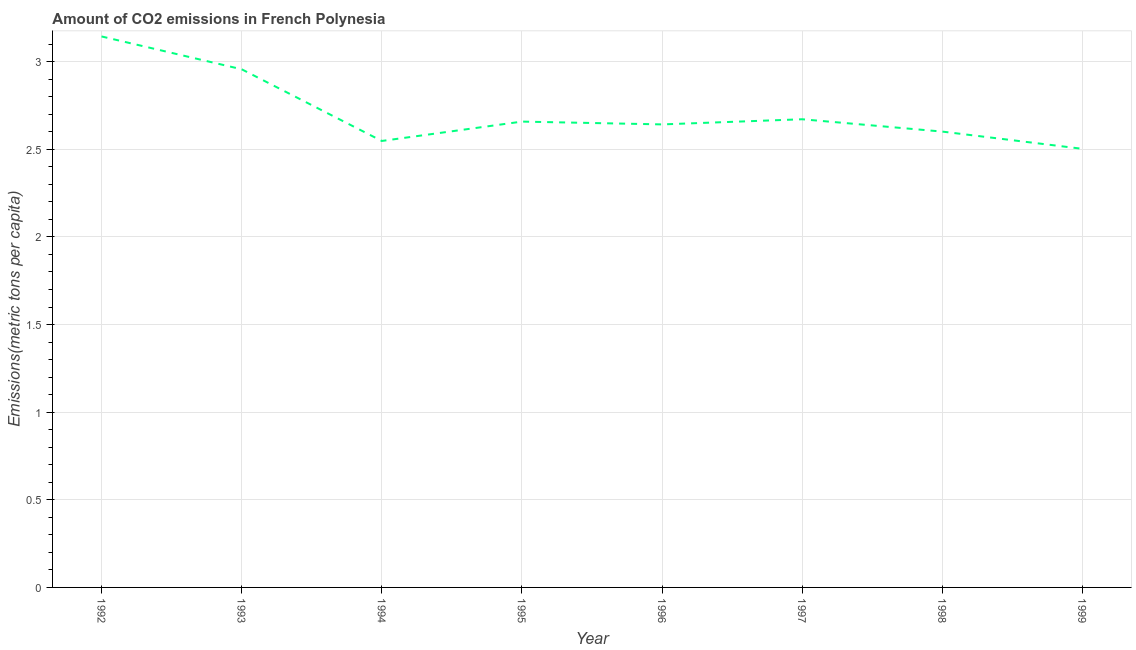What is the amount of co2 emissions in 1999?
Make the answer very short. 2.5. Across all years, what is the maximum amount of co2 emissions?
Offer a very short reply. 3.14. Across all years, what is the minimum amount of co2 emissions?
Ensure brevity in your answer.  2.5. What is the sum of the amount of co2 emissions?
Provide a short and direct response. 21.72. What is the difference between the amount of co2 emissions in 1992 and 1998?
Make the answer very short. 0.54. What is the average amount of co2 emissions per year?
Your answer should be compact. 2.72. What is the median amount of co2 emissions?
Ensure brevity in your answer.  2.65. What is the ratio of the amount of co2 emissions in 1993 to that in 1998?
Your response must be concise. 1.14. What is the difference between the highest and the second highest amount of co2 emissions?
Provide a short and direct response. 0.19. Is the sum of the amount of co2 emissions in 1994 and 1999 greater than the maximum amount of co2 emissions across all years?
Offer a very short reply. Yes. What is the difference between the highest and the lowest amount of co2 emissions?
Offer a terse response. 0.64. In how many years, is the amount of co2 emissions greater than the average amount of co2 emissions taken over all years?
Keep it short and to the point. 2. Does the amount of co2 emissions monotonically increase over the years?
Offer a terse response. No. How many lines are there?
Your response must be concise. 1. What is the difference between two consecutive major ticks on the Y-axis?
Provide a short and direct response. 0.5. Does the graph contain any zero values?
Your response must be concise. No. Does the graph contain grids?
Your response must be concise. Yes. What is the title of the graph?
Provide a succinct answer. Amount of CO2 emissions in French Polynesia. What is the label or title of the X-axis?
Provide a short and direct response. Year. What is the label or title of the Y-axis?
Provide a succinct answer. Emissions(metric tons per capita). What is the Emissions(metric tons per capita) in 1992?
Ensure brevity in your answer.  3.14. What is the Emissions(metric tons per capita) of 1993?
Make the answer very short. 2.96. What is the Emissions(metric tons per capita) of 1994?
Keep it short and to the point. 2.55. What is the Emissions(metric tons per capita) in 1995?
Your answer should be very brief. 2.66. What is the Emissions(metric tons per capita) in 1996?
Make the answer very short. 2.64. What is the Emissions(metric tons per capita) in 1997?
Provide a short and direct response. 2.67. What is the Emissions(metric tons per capita) in 1998?
Keep it short and to the point. 2.6. What is the Emissions(metric tons per capita) of 1999?
Your response must be concise. 2.5. What is the difference between the Emissions(metric tons per capita) in 1992 and 1993?
Ensure brevity in your answer.  0.19. What is the difference between the Emissions(metric tons per capita) in 1992 and 1994?
Provide a short and direct response. 0.6. What is the difference between the Emissions(metric tons per capita) in 1992 and 1995?
Provide a succinct answer. 0.49. What is the difference between the Emissions(metric tons per capita) in 1992 and 1996?
Offer a very short reply. 0.5. What is the difference between the Emissions(metric tons per capita) in 1992 and 1997?
Offer a very short reply. 0.47. What is the difference between the Emissions(metric tons per capita) in 1992 and 1998?
Provide a succinct answer. 0.54. What is the difference between the Emissions(metric tons per capita) in 1992 and 1999?
Offer a very short reply. 0.64. What is the difference between the Emissions(metric tons per capita) in 1993 and 1994?
Provide a short and direct response. 0.41. What is the difference between the Emissions(metric tons per capita) in 1993 and 1995?
Offer a terse response. 0.3. What is the difference between the Emissions(metric tons per capita) in 1993 and 1996?
Offer a terse response. 0.31. What is the difference between the Emissions(metric tons per capita) in 1993 and 1997?
Ensure brevity in your answer.  0.29. What is the difference between the Emissions(metric tons per capita) in 1993 and 1998?
Provide a short and direct response. 0.36. What is the difference between the Emissions(metric tons per capita) in 1993 and 1999?
Make the answer very short. 0.45. What is the difference between the Emissions(metric tons per capita) in 1994 and 1995?
Your response must be concise. -0.11. What is the difference between the Emissions(metric tons per capita) in 1994 and 1996?
Make the answer very short. -0.09. What is the difference between the Emissions(metric tons per capita) in 1994 and 1997?
Provide a succinct answer. -0.12. What is the difference between the Emissions(metric tons per capita) in 1994 and 1998?
Offer a very short reply. -0.05. What is the difference between the Emissions(metric tons per capita) in 1994 and 1999?
Your answer should be compact. 0.04. What is the difference between the Emissions(metric tons per capita) in 1995 and 1996?
Offer a very short reply. 0.02. What is the difference between the Emissions(metric tons per capita) in 1995 and 1997?
Your answer should be compact. -0.01. What is the difference between the Emissions(metric tons per capita) in 1995 and 1998?
Provide a short and direct response. 0.06. What is the difference between the Emissions(metric tons per capita) in 1995 and 1999?
Your answer should be compact. 0.16. What is the difference between the Emissions(metric tons per capita) in 1996 and 1997?
Your answer should be compact. -0.03. What is the difference between the Emissions(metric tons per capita) in 1996 and 1998?
Keep it short and to the point. 0.04. What is the difference between the Emissions(metric tons per capita) in 1996 and 1999?
Your answer should be compact. 0.14. What is the difference between the Emissions(metric tons per capita) in 1997 and 1998?
Keep it short and to the point. 0.07. What is the difference between the Emissions(metric tons per capita) in 1997 and 1999?
Provide a short and direct response. 0.17. What is the difference between the Emissions(metric tons per capita) in 1998 and 1999?
Provide a succinct answer. 0.1. What is the ratio of the Emissions(metric tons per capita) in 1992 to that in 1993?
Your response must be concise. 1.06. What is the ratio of the Emissions(metric tons per capita) in 1992 to that in 1994?
Provide a short and direct response. 1.23. What is the ratio of the Emissions(metric tons per capita) in 1992 to that in 1995?
Offer a terse response. 1.18. What is the ratio of the Emissions(metric tons per capita) in 1992 to that in 1996?
Your answer should be compact. 1.19. What is the ratio of the Emissions(metric tons per capita) in 1992 to that in 1997?
Provide a short and direct response. 1.18. What is the ratio of the Emissions(metric tons per capita) in 1992 to that in 1998?
Give a very brief answer. 1.21. What is the ratio of the Emissions(metric tons per capita) in 1992 to that in 1999?
Your answer should be very brief. 1.26. What is the ratio of the Emissions(metric tons per capita) in 1993 to that in 1994?
Keep it short and to the point. 1.16. What is the ratio of the Emissions(metric tons per capita) in 1993 to that in 1995?
Your answer should be very brief. 1.11. What is the ratio of the Emissions(metric tons per capita) in 1993 to that in 1996?
Your answer should be very brief. 1.12. What is the ratio of the Emissions(metric tons per capita) in 1993 to that in 1997?
Offer a terse response. 1.11. What is the ratio of the Emissions(metric tons per capita) in 1993 to that in 1998?
Make the answer very short. 1.14. What is the ratio of the Emissions(metric tons per capita) in 1993 to that in 1999?
Keep it short and to the point. 1.18. What is the ratio of the Emissions(metric tons per capita) in 1994 to that in 1995?
Offer a terse response. 0.96. What is the ratio of the Emissions(metric tons per capita) in 1994 to that in 1996?
Ensure brevity in your answer.  0.96. What is the ratio of the Emissions(metric tons per capita) in 1994 to that in 1997?
Offer a terse response. 0.95. What is the ratio of the Emissions(metric tons per capita) in 1994 to that in 1998?
Provide a short and direct response. 0.98. What is the ratio of the Emissions(metric tons per capita) in 1994 to that in 1999?
Give a very brief answer. 1.02. What is the ratio of the Emissions(metric tons per capita) in 1995 to that in 1996?
Give a very brief answer. 1.01. What is the ratio of the Emissions(metric tons per capita) in 1995 to that in 1998?
Your answer should be very brief. 1.02. What is the ratio of the Emissions(metric tons per capita) in 1995 to that in 1999?
Make the answer very short. 1.06. What is the ratio of the Emissions(metric tons per capita) in 1996 to that in 1999?
Provide a succinct answer. 1.06. What is the ratio of the Emissions(metric tons per capita) in 1997 to that in 1999?
Ensure brevity in your answer.  1.07. What is the ratio of the Emissions(metric tons per capita) in 1998 to that in 1999?
Keep it short and to the point. 1.04. 